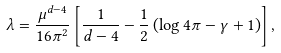<formula> <loc_0><loc_0><loc_500><loc_500>\lambda = \frac { \mu ^ { d - 4 } } { 1 6 \pi ^ { 2 } } \left [ \frac { 1 } { d - 4 } - \frac { 1 } { 2 } \left ( \log 4 \pi - \gamma + 1 \right ) \right ] ,</formula> 